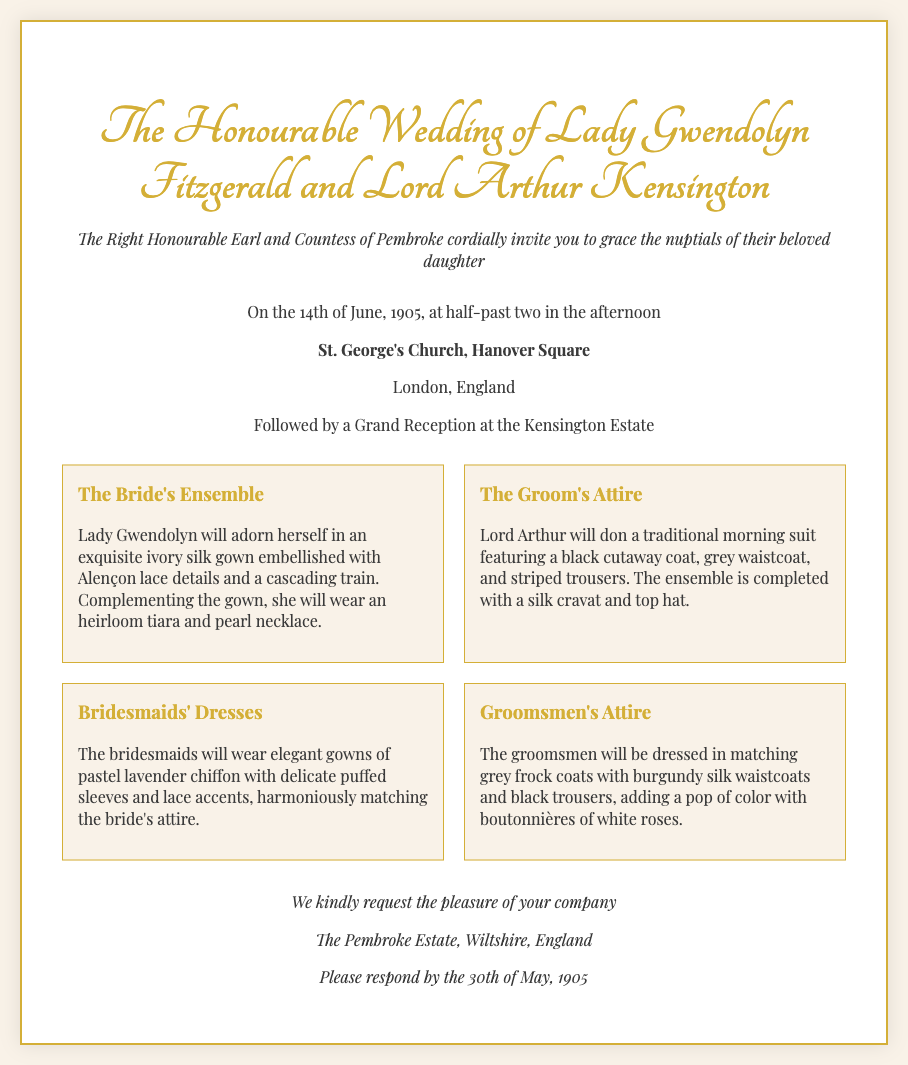What is the date of the wedding? The date of the wedding is explicitly stated in the document as the 14th of June, 1905.
Answer: 14th of June, 1905 Who is the bride? The document announces the wedding of Lady Gwendolyn Fitzgerald, making her the bride.
Answer: Lady Gwendolyn Fitzgerald What is the location of the ceremony? The location for the wedding ceremony is mentioned in the invitation, St. George's Church, Hanover Square, London.
Answer: St. George's Church, Hanover Square What type of gown will the bride wear? The invitation describes the bride's ensemble as an ivory silk gown, specifying its details and fabric.
Answer: ivory silk gown What color are the bridesmaids' dresses? The document states that the bridesmaids will wear pastel lavender chiffon gowns.
Answer: pastel lavender What is the groom's title? The document identifies the groom as Lord Arthur Kensington, providing his title.
Answer: Lord What do the groomsmen's waistcoats look like? The invitation describes the groomsmen's waistcoats as burgundy silk, indicating their color and material.
Answer: burgundy silk By when should guests respond? The invitation specifies the deadline for RSVPs, which is set as the 30th of May, 1905.
Answer: 30th of May, 1905 What is the host's title? The document mentions the hosts as The Right Honourable Earl and Countess of Pembroke, identifying their titles.
Answer: Earl and Countess 